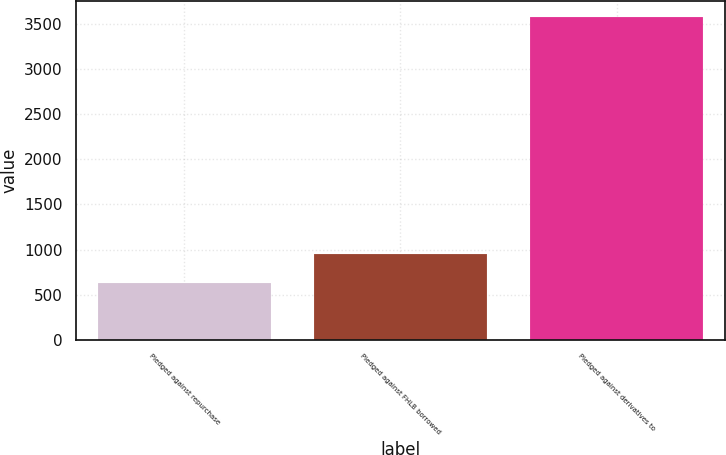Convert chart to OTSL. <chart><loc_0><loc_0><loc_500><loc_500><bar_chart><fcel>Pledged against repurchase<fcel>Pledged against FHLB borrowed<fcel>Pledged against derivatives to<nl><fcel>631<fcel>953<fcel>3575<nl></chart> 